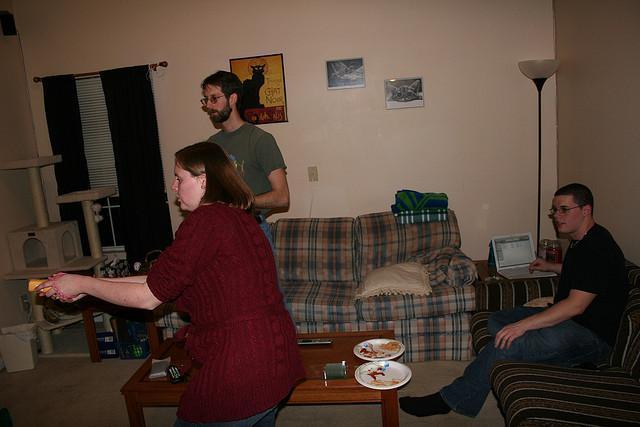How many people are in the picture on the mantle?
Give a very brief answer. 0. How many picture frames are seen on the wall?
Give a very brief answer. 3. How many visible tattoos are there?
Give a very brief answer. 0. How many people are wearing glasses?
Give a very brief answer. 2. How many laptops are visible?
Give a very brief answer. 1. How many people?
Give a very brief answer. 3. How many people are standing?
Give a very brief answer. 2. How many people are seated?
Give a very brief answer. 1. How many couches are in the picture?
Give a very brief answer. 2. How many people are visible?
Give a very brief answer. 3. How many clocks are in the photo?
Give a very brief answer. 0. 